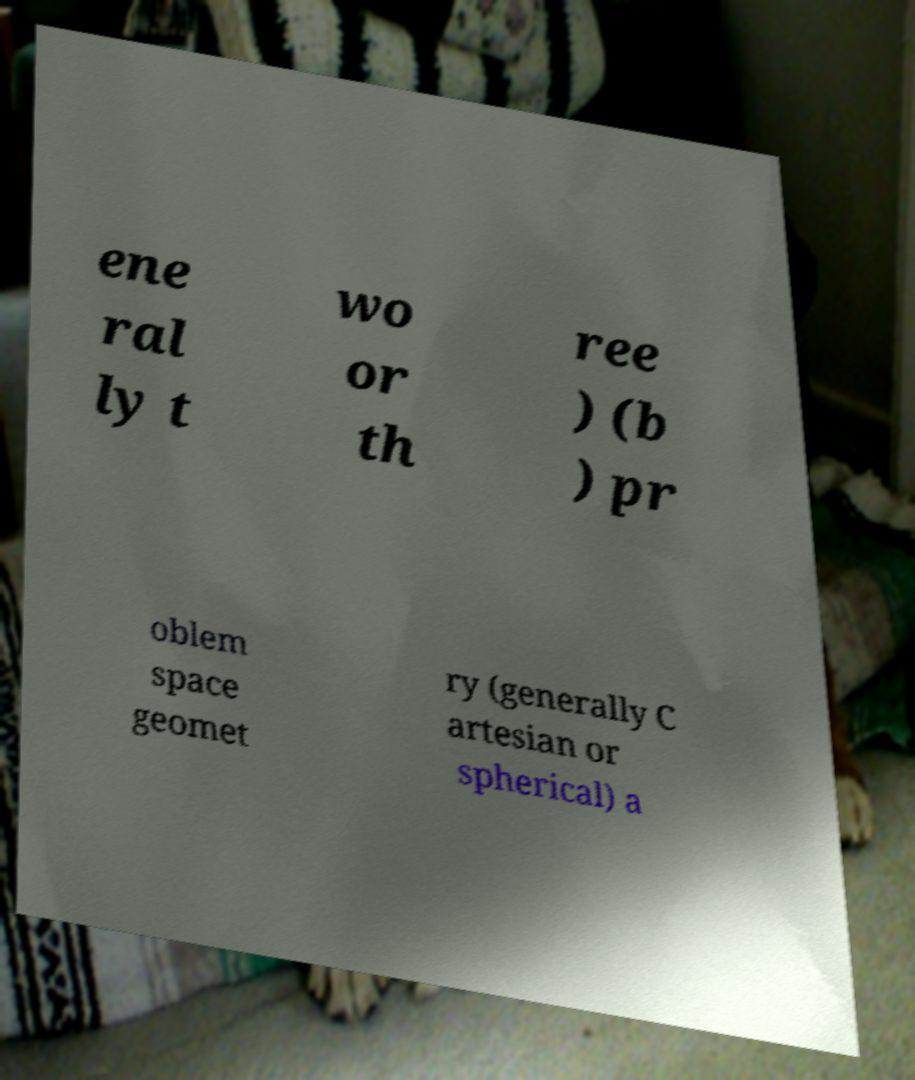Could you assist in decoding the text presented in this image and type it out clearly? ene ral ly t wo or th ree ) (b ) pr oblem space geomet ry (generally C artesian or spherical) a 